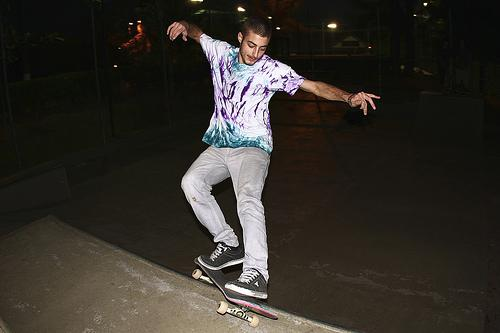Describe the setting of the skateboarding park in the image. The skatepark has a grey concrete wall, a ramp, an obstacle, and a fence, with shadows cast on the ground and kids standing nearby. Comment on the skateboard and its design elements observed in the image. The skateboard has yellow wheels and features a red and black design, positioned on a ramp in the skatepark. Write a concise description of the central figure in the photograph. A skateboarder with facial hair, wearing a tie-dyed shirt and blue jeans, is performing a trick at a skatepark. Summarize the key features of the image in a single sentence. A man skateboards on a concrete ramp at night, wearing colorful clothes and black sneakers, with a lit background. Briefly describe the lower half of the skateboarder's attire and his footwear. The man is wearing faded blue jeans and black tennis shoes with white details while skateboarding on the ramp. Mention the pose and facial features of the man as he skateboards. The man, with facial hair and a mustache, looks down at the ground while stretching his arms out as he skateboards. Describe the nighttime environment surrounding the skateboarder. The picture is taken at night with artificial light in the background, a fence around the skateboard park, distant street lights, and a house behind the park. Provide a brief overview of the scene captured in the image. A man is skateboarding at night in a park, wearing multicolored attire with black sneakers, and performing a stunt on a ramp. Identify the clothing items and accessories worn by the man in the image. The man wears a multicolored t-shirt, gray jeans, black sneakers, and a wristwatch while skateboarding. What is the primary action taking place in the image, and what is the light source at the scene? A man is skateboarding on a cement ramp under artificial light and the faint glow of distant street lights. 